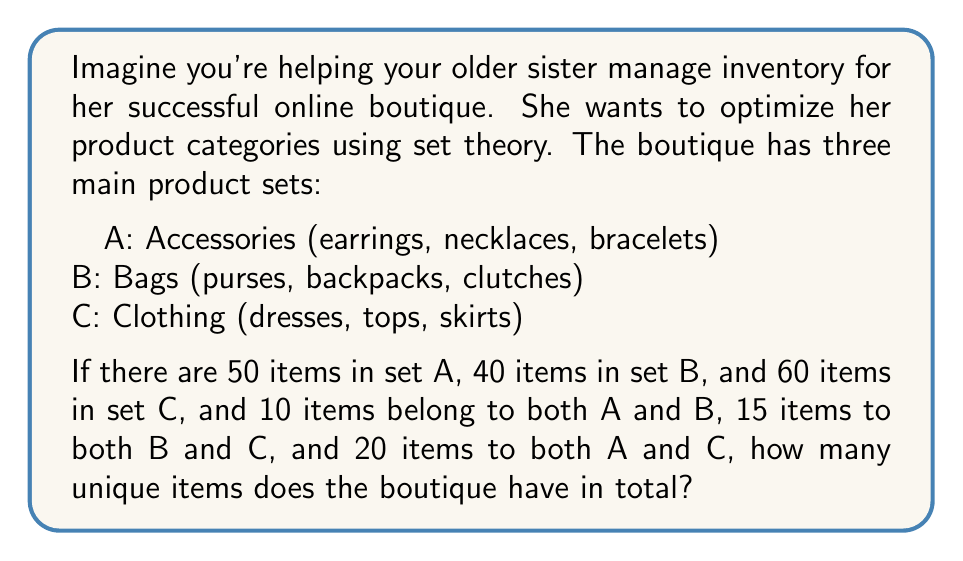Can you answer this question? Let's approach this step-by-step using set theory:

1. We need to find the total number of unique items, which is represented by the union of sets A, B, and C: $|A \cup B \cup C|$

2. We can use the inclusion-exclusion principle:

   $|A \cup B \cup C| = |A| + |B| + |C| - |A \cap B| - |B \cap C| - |A \cap C| + |A \cap B \cap C|$

3. We know:
   $|A| = 50$
   $|B| = 40$
   $|C| = 60$
   $|A \cap B| = 10$
   $|B \cap C| = 15$
   $|A \cap C| = 20$

4. We don't know $|A \cap B \cap C|$, but we can assume it's 0 for this problem (no item belongs to all three categories).

5. Now, let's substitute these values into our equation:

   $|A \cup B \cup C| = 50 + 40 + 60 - 10 - 15 - 20 + 0$

6. Simplifying:
   $|A \cup B \cup C| = 150 - 45 = 105$

Therefore, the boutique has 105 unique items in total.
Answer: 105 unique items 